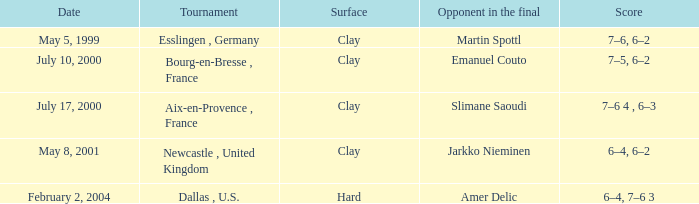What is the Opponent in the final of the game on february 2, 2004? Amer Delic. 